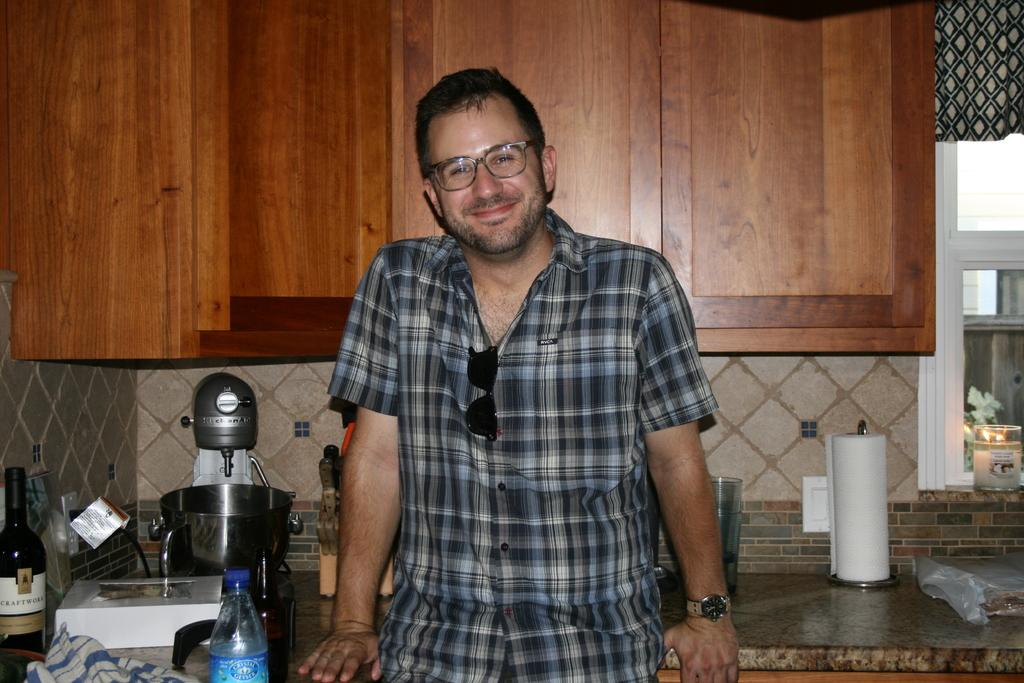What is the main subject of the image? There is a man standing in the image. Where does the image appear to be set? The image appears to be set in a kitchen. What type of appliance can be seen in the kitchen? There is a cake making machine in the kitchen. What else can be seen in the kitchen besides the man and the cake making machine? There are bottles and cupboards in the kitchen. How many buns are sitting on the clock in the image? There is no clock or buns present in the image. What effect does the man's presence have on the functioning of the cake making machine? The man's presence does not have any effect on the functioning of the cake making machine, as he is simply standing in the kitchen. 